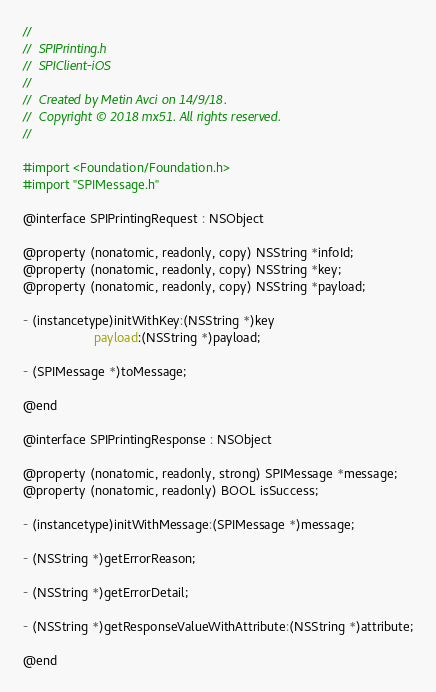Convert code to text. <code><loc_0><loc_0><loc_500><loc_500><_C_>//
//  SPIPrinting.h
//  SPIClient-iOS
//
//  Created by Metin Avci on 14/9/18.
//  Copyright © 2018 mx51. All rights reserved.
//

#import <Foundation/Foundation.h>
#import "SPIMessage.h"

@interface SPIPrintingRequest : NSObject

@property (nonatomic, readonly, copy) NSString *infoId;
@property (nonatomic, readonly, copy) NSString *key;
@property (nonatomic, readonly, copy) NSString *payload;

- (instancetype)initWithKey:(NSString *)key
                    payload:(NSString *)payload;

- (SPIMessage *)toMessage;

@end

@interface SPIPrintingResponse : NSObject

@property (nonatomic, readonly, strong) SPIMessage *message;
@property (nonatomic, readonly) BOOL isSuccess;

- (instancetype)initWithMessage:(SPIMessage *)message;

- (NSString *)getErrorReason;

- (NSString *)getErrorDetail;

- (NSString *)getResponseValueWithAttribute:(NSString *)attribute;

@end
</code> 